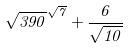Convert formula to latex. <formula><loc_0><loc_0><loc_500><loc_500>\sqrt { 3 9 0 } ^ { \sqrt { 7 } } + \frac { 6 } { \sqrt { 1 0 } }</formula> 